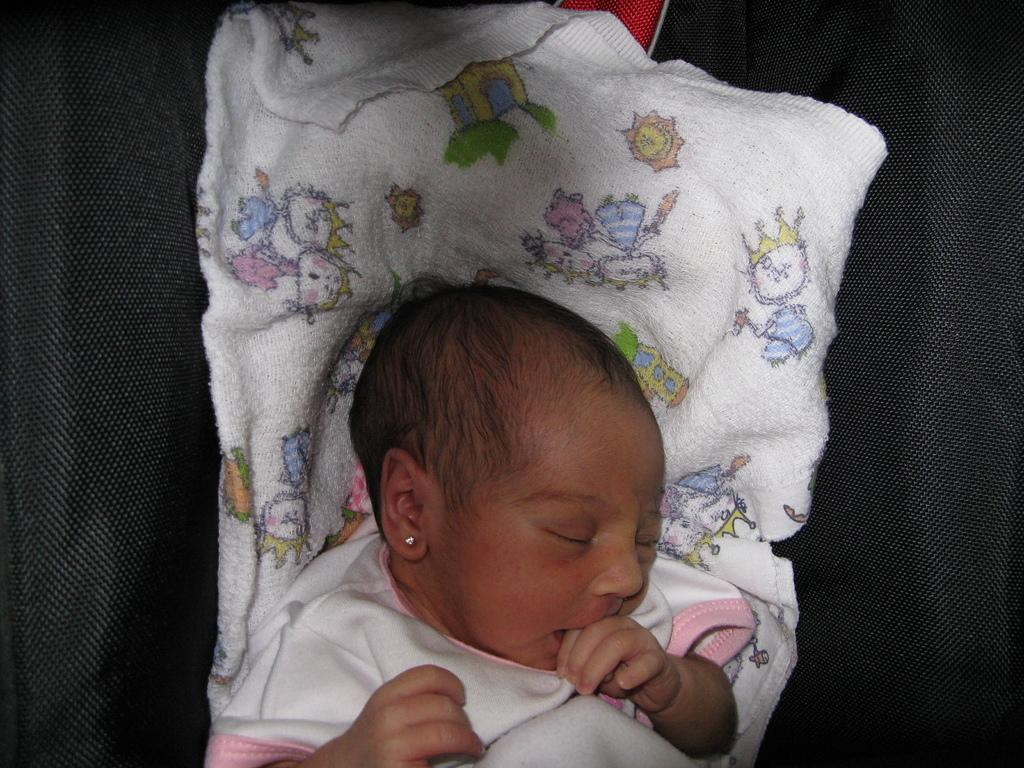What is the main subject of the image? There is a baby in the image. What is the baby lying on? The baby is lying on a cloth. What is the cloth placed on? The cloth is on a black object. Can you tell me how many arms the baby's grandmother has in the image? There is no grandmother present in the image, and therefore no arms to count. 